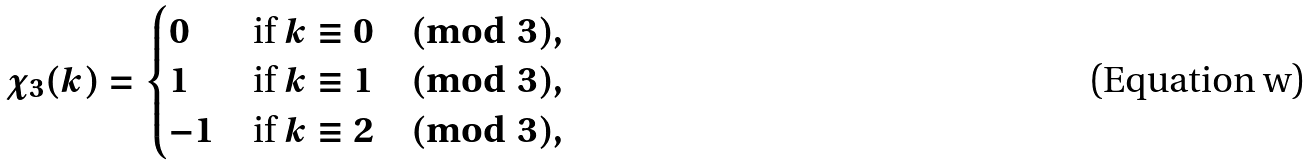<formula> <loc_0><loc_0><loc_500><loc_500>\chi _ { 3 } ( k ) = \begin{cases} 0 & \text {if} \ k \equiv 0 \pmod { 3 } , \\ 1 & \text {if} \ k \equiv 1 \pmod { 3 } , \\ - 1 & \text {if} \ k \equiv 2 \pmod { 3 } , \\ \end{cases}</formula> 